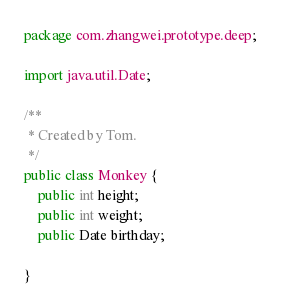<code> <loc_0><loc_0><loc_500><loc_500><_Java_>package com.zhangwei.prototype.deep;

import java.util.Date;

/**
 * Created by Tom.
 */
public class Monkey {
    public int height;
    public int weight;
    public Date birthday;

}
</code> 